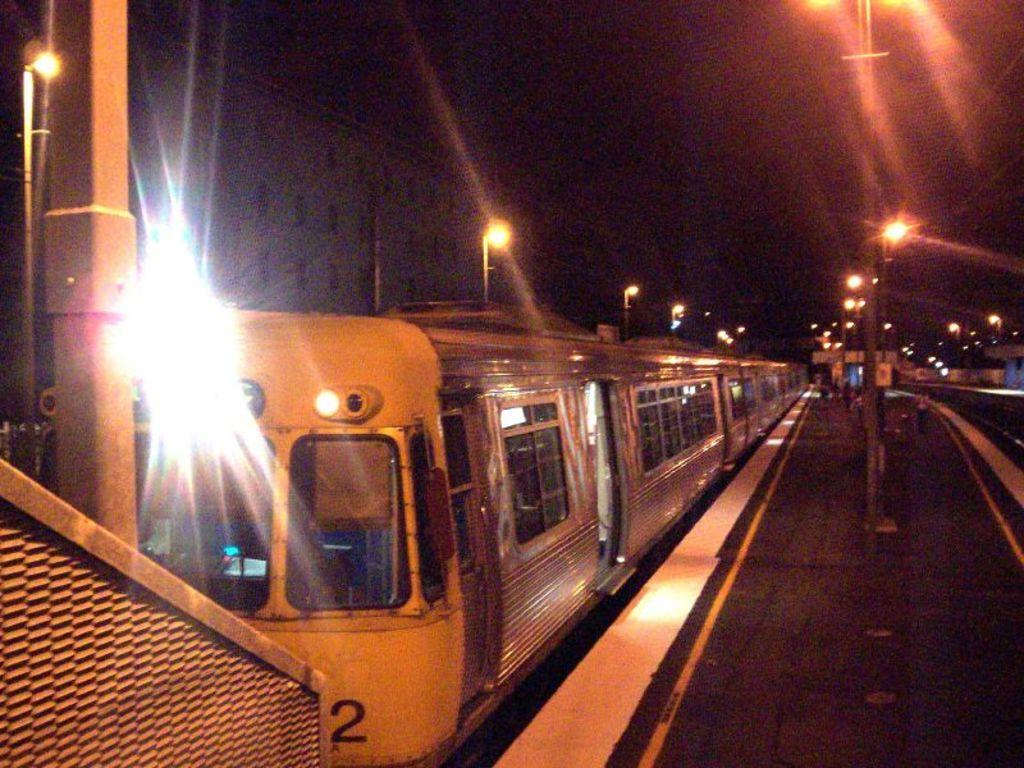<image>
Provide a brief description of the given image. A yellow train marked with the number two is boarding passengers. 